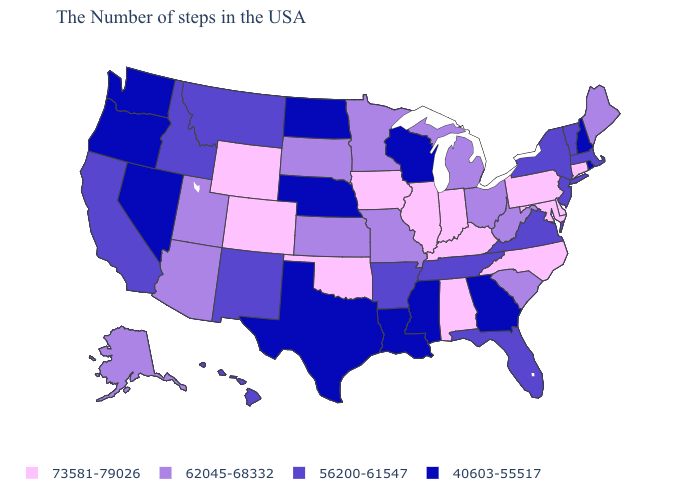What is the value of Montana?
Quick response, please. 56200-61547. Does South Carolina have a higher value than Pennsylvania?
Answer briefly. No. Does West Virginia have a higher value than Hawaii?
Be succinct. Yes. Is the legend a continuous bar?
Short answer required. No. Does New Mexico have the highest value in the USA?
Answer briefly. No. Which states have the lowest value in the USA?
Quick response, please. Rhode Island, New Hampshire, Georgia, Wisconsin, Mississippi, Louisiana, Nebraska, Texas, North Dakota, Nevada, Washington, Oregon. Among the states that border Texas , does Louisiana have the lowest value?
Quick response, please. Yes. Among the states that border North Dakota , does Montana have the highest value?
Short answer required. No. What is the value of Delaware?
Give a very brief answer. 73581-79026. Among the states that border Utah , which have the lowest value?
Concise answer only. Nevada. Among the states that border Mississippi , which have the lowest value?
Give a very brief answer. Louisiana. Among the states that border Mississippi , does Alabama have the lowest value?
Keep it brief. No. Name the states that have a value in the range 40603-55517?
Keep it brief. Rhode Island, New Hampshire, Georgia, Wisconsin, Mississippi, Louisiana, Nebraska, Texas, North Dakota, Nevada, Washington, Oregon. What is the value of Washington?
Quick response, please. 40603-55517. What is the value of Ohio?
Quick response, please. 62045-68332. 